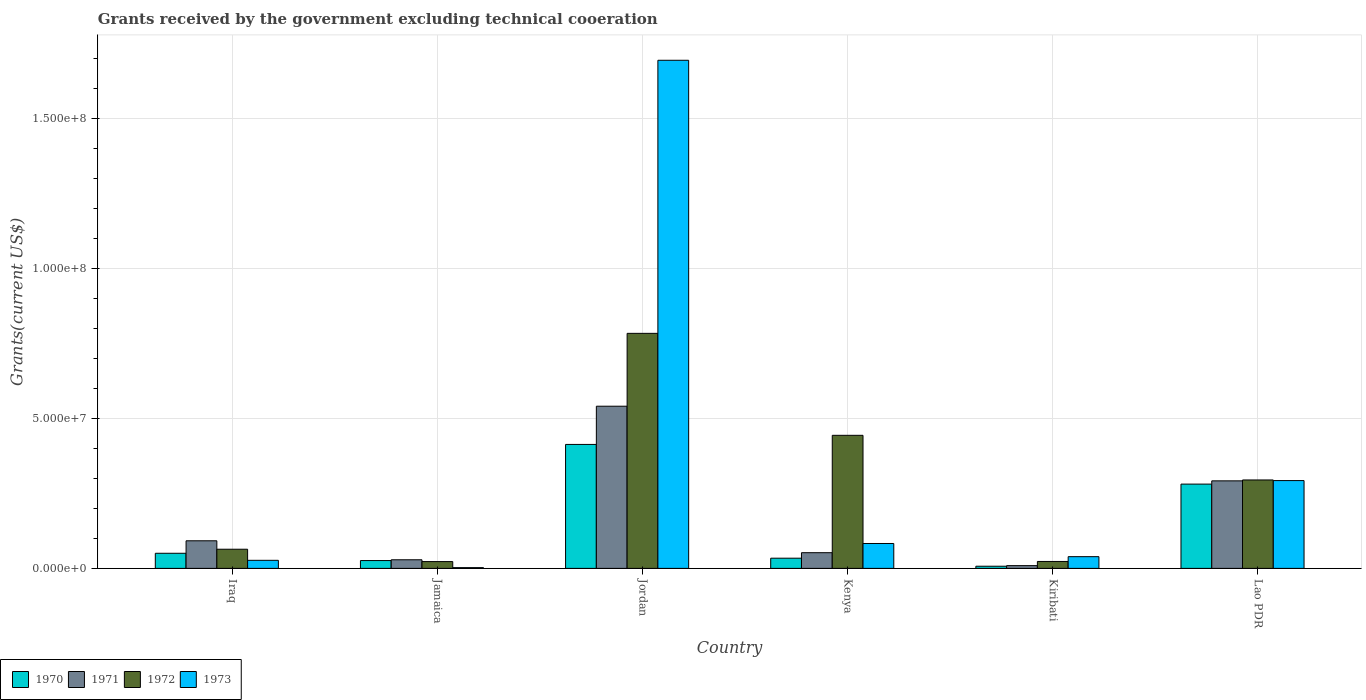Are the number of bars on each tick of the X-axis equal?
Offer a very short reply. Yes. What is the label of the 1st group of bars from the left?
Keep it short and to the point. Iraq. In how many cases, is the number of bars for a given country not equal to the number of legend labels?
Make the answer very short. 0. What is the total grants received by the government in 1972 in Lao PDR?
Give a very brief answer. 2.95e+07. Across all countries, what is the maximum total grants received by the government in 1970?
Offer a very short reply. 4.13e+07. In which country was the total grants received by the government in 1972 maximum?
Your answer should be compact. Jordan. In which country was the total grants received by the government in 1973 minimum?
Keep it short and to the point. Jamaica. What is the total total grants received by the government in 1973 in the graph?
Provide a short and direct response. 2.14e+08. What is the difference between the total grants received by the government in 1973 in Iraq and that in Jordan?
Your response must be concise. -1.67e+08. What is the difference between the total grants received by the government in 1971 in Iraq and the total grants received by the government in 1970 in Jordan?
Offer a terse response. -3.21e+07. What is the average total grants received by the government in 1970 per country?
Provide a short and direct response. 1.35e+07. In how many countries, is the total grants received by the government in 1970 greater than 150000000 US$?
Offer a terse response. 0. What is the ratio of the total grants received by the government in 1973 in Jamaica to that in Kiribati?
Make the answer very short. 0.06. Is the total grants received by the government in 1973 in Jordan less than that in Kiribati?
Give a very brief answer. No. Is the difference between the total grants received by the government in 1971 in Kenya and Kiribati greater than the difference between the total grants received by the government in 1972 in Kenya and Kiribati?
Ensure brevity in your answer.  No. What is the difference between the highest and the second highest total grants received by the government in 1973?
Provide a short and direct response. 1.61e+08. What is the difference between the highest and the lowest total grants received by the government in 1972?
Keep it short and to the point. 7.61e+07. Is it the case that in every country, the sum of the total grants received by the government in 1972 and total grants received by the government in 1971 is greater than the sum of total grants received by the government in 1973 and total grants received by the government in 1970?
Give a very brief answer. No. What does the 3rd bar from the left in Jamaica represents?
Provide a short and direct response. 1972. What does the 1st bar from the right in Kenya represents?
Provide a succinct answer. 1973. Is it the case that in every country, the sum of the total grants received by the government in 1973 and total grants received by the government in 1970 is greater than the total grants received by the government in 1972?
Your response must be concise. No. How many countries are there in the graph?
Offer a very short reply. 6. Are the values on the major ticks of Y-axis written in scientific E-notation?
Offer a terse response. Yes. Where does the legend appear in the graph?
Give a very brief answer. Bottom left. How are the legend labels stacked?
Make the answer very short. Horizontal. What is the title of the graph?
Your answer should be compact. Grants received by the government excluding technical cooeration. What is the label or title of the Y-axis?
Make the answer very short. Grants(current US$). What is the Grants(current US$) of 1970 in Iraq?
Your answer should be compact. 5.04e+06. What is the Grants(current US$) in 1971 in Iraq?
Offer a very short reply. 9.20e+06. What is the Grants(current US$) of 1972 in Iraq?
Keep it short and to the point. 6.39e+06. What is the Grants(current US$) of 1973 in Iraq?
Your response must be concise. 2.69e+06. What is the Grants(current US$) of 1970 in Jamaica?
Offer a very short reply. 2.61e+06. What is the Grants(current US$) in 1971 in Jamaica?
Keep it short and to the point. 2.87e+06. What is the Grants(current US$) of 1972 in Jamaica?
Ensure brevity in your answer.  2.27e+06. What is the Grants(current US$) of 1973 in Jamaica?
Your response must be concise. 2.50e+05. What is the Grants(current US$) in 1970 in Jordan?
Provide a succinct answer. 4.13e+07. What is the Grants(current US$) in 1971 in Jordan?
Offer a very short reply. 5.41e+07. What is the Grants(current US$) in 1972 in Jordan?
Your answer should be very brief. 7.84e+07. What is the Grants(current US$) in 1973 in Jordan?
Make the answer very short. 1.69e+08. What is the Grants(current US$) in 1970 in Kenya?
Keep it short and to the point. 3.40e+06. What is the Grants(current US$) in 1971 in Kenya?
Ensure brevity in your answer.  5.23e+06. What is the Grants(current US$) in 1972 in Kenya?
Your answer should be very brief. 4.44e+07. What is the Grants(current US$) in 1973 in Kenya?
Provide a succinct answer. 8.30e+06. What is the Grants(current US$) in 1970 in Kiribati?
Provide a short and direct response. 7.20e+05. What is the Grants(current US$) of 1971 in Kiribati?
Keep it short and to the point. 9.20e+05. What is the Grants(current US$) in 1972 in Kiribati?
Give a very brief answer. 2.31e+06. What is the Grants(current US$) in 1973 in Kiribati?
Ensure brevity in your answer.  3.91e+06. What is the Grants(current US$) of 1970 in Lao PDR?
Keep it short and to the point. 2.81e+07. What is the Grants(current US$) of 1971 in Lao PDR?
Make the answer very short. 2.92e+07. What is the Grants(current US$) of 1972 in Lao PDR?
Make the answer very short. 2.95e+07. What is the Grants(current US$) of 1973 in Lao PDR?
Offer a very short reply. 2.93e+07. Across all countries, what is the maximum Grants(current US$) in 1970?
Offer a very short reply. 4.13e+07. Across all countries, what is the maximum Grants(current US$) of 1971?
Offer a terse response. 5.41e+07. Across all countries, what is the maximum Grants(current US$) of 1972?
Keep it short and to the point. 7.84e+07. Across all countries, what is the maximum Grants(current US$) of 1973?
Provide a succinct answer. 1.69e+08. Across all countries, what is the minimum Grants(current US$) of 1970?
Offer a terse response. 7.20e+05. Across all countries, what is the minimum Grants(current US$) in 1971?
Provide a succinct answer. 9.20e+05. Across all countries, what is the minimum Grants(current US$) in 1972?
Your answer should be very brief. 2.27e+06. Across all countries, what is the minimum Grants(current US$) of 1973?
Ensure brevity in your answer.  2.50e+05. What is the total Grants(current US$) of 1970 in the graph?
Your response must be concise. 8.12e+07. What is the total Grants(current US$) in 1971 in the graph?
Make the answer very short. 1.01e+08. What is the total Grants(current US$) of 1972 in the graph?
Your response must be concise. 1.63e+08. What is the total Grants(current US$) in 1973 in the graph?
Ensure brevity in your answer.  2.14e+08. What is the difference between the Grants(current US$) of 1970 in Iraq and that in Jamaica?
Your response must be concise. 2.43e+06. What is the difference between the Grants(current US$) in 1971 in Iraq and that in Jamaica?
Provide a succinct answer. 6.33e+06. What is the difference between the Grants(current US$) in 1972 in Iraq and that in Jamaica?
Offer a very short reply. 4.12e+06. What is the difference between the Grants(current US$) of 1973 in Iraq and that in Jamaica?
Offer a very short reply. 2.44e+06. What is the difference between the Grants(current US$) of 1970 in Iraq and that in Jordan?
Make the answer very short. -3.63e+07. What is the difference between the Grants(current US$) of 1971 in Iraq and that in Jordan?
Keep it short and to the point. -4.49e+07. What is the difference between the Grants(current US$) of 1972 in Iraq and that in Jordan?
Offer a very short reply. -7.20e+07. What is the difference between the Grants(current US$) of 1973 in Iraq and that in Jordan?
Your response must be concise. -1.67e+08. What is the difference between the Grants(current US$) in 1970 in Iraq and that in Kenya?
Offer a terse response. 1.64e+06. What is the difference between the Grants(current US$) in 1971 in Iraq and that in Kenya?
Make the answer very short. 3.97e+06. What is the difference between the Grants(current US$) of 1972 in Iraq and that in Kenya?
Provide a short and direct response. -3.80e+07. What is the difference between the Grants(current US$) of 1973 in Iraq and that in Kenya?
Keep it short and to the point. -5.61e+06. What is the difference between the Grants(current US$) of 1970 in Iraq and that in Kiribati?
Provide a short and direct response. 4.32e+06. What is the difference between the Grants(current US$) of 1971 in Iraq and that in Kiribati?
Your answer should be very brief. 8.28e+06. What is the difference between the Grants(current US$) of 1972 in Iraq and that in Kiribati?
Offer a very short reply. 4.08e+06. What is the difference between the Grants(current US$) in 1973 in Iraq and that in Kiribati?
Provide a short and direct response. -1.22e+06. What is the difference between the Grants(current US$) in 1970 in Iraq and that in Lao PDR?
Ensure brevity in your answer.  -2.31e+07. What is the difference between the Grants(current US$) of 1971 in Iraq and that in Lao PDR?
Offer a very short reply. -2.00e+07. What is the difference between the Grants(current US$) of 1972 in Iraq and that in Lao PDR?
Your response must be concise. -2.31e+07. What is the difference between the Grants(current US$) in 1973 in Iraq and that in Lao PDR?
Your answer should be very brief. -2.66e+07. What is the difference between the Grants(current US$) of 1970 in Jamaica and that in Jordan?
Provide a succinct answer. -3.87e+07. What is the difference between the Grants(current US$) in 1971 in Jamaica and that in Jordan?
Make the answer very short. -5.12e+07. What is the difference between the Grants(current US$) in 1972 in Jamaica and that in Jordan?
Provide a succinct answer. -7.61e+07. What is the difference between the Grants(current US$) of 1973 in Jamaica and that in Jordan?
Offer a very short reply. -1.69e+08. What is the difference between the Grants(current US$) of 1970 in Jamaica and that in Kenya?
Your response must be concise. -7.90e+05. What is the difference between the Grants(current US$) of 1971 in Jamaica and that in Kenya?
Your answer should be compact. -2.36e+06. What is the difference between the Grants(current US$) in 1972 in Jamaica and that in Kenya?
Provide a short and direct response. -4.21e+07. What is the difference between the Grants(current US$) of 1973 in Jamaica and that in Kenya?
Your answer should be very brief. -8.05e+06. What is the difference between the Grants(current US$) of 1970 in Jamaica and that in Kiribati?
Give a very brief answer. 1.89e+06. What is the difference between the Grants(current US$) of 1971 in Jamaica and that in Kiribati?
Ensure brevity in your answer.  1.95e+06. What is the difference between the Grants(current US$) in 1972 in Jamaica and that in Kiribati?
Ensure brevity in your answer.  -4.00e+04. What is the difference between the Grants(current US$) in 1973 in Jamaica and that in Kiribati?
Your answer should be very brief. -3.66e+06. What is the difference between the Grants(current US$) of 1970 in Jamaica and that in Lao PDR?
Provide a short and direct response. -2.55e+07. What is the difference between the Grants(current US$) in 1971 in Jamaica and that in Lao PDR?
Ensure brevity in your answer.  -2.63e+07. What is the difference between the Grants(current US$) of 1972 in Jamaica and that in Lao PDR?
Provide a short and direct response. -2.72e+07. What is the difference between the Grants(current US$) in 1973 in Jamaica and that in Lao PDR?
Provide a succinct answer. -2.90e+07. What is the difference between the Grants(current US$) in 1970 in Jordan and that in Kenya?
Keep it short and to the point. 3.79e+07. What is the difference between the Grants(current US$) in 1971 in Jordan and that in Kenya?
Your answer should be compact. 4.88e+07. What is the difference between the Grants(current US$) in 1972 in Jordan and that in Kenya?
Offer a very short reply. 3.40e+07. What is the difference between the Grants(current US$) of 1973 in Jordan and that in Kenya?
Offer a terse response. 1.61e+08. What is the difference between the Grants(current US$) of 1970 in Jordan and that in Kiribati?
Your response must be concise. 4.06e+07. What is the difference between the Grants(current US$) in 1971 in Jordan and that in Kiribati?
Your response must be concise. 5.31e+07. What is the difference between the Grants(current US$) of 1972 in Jordan and that in Kiribati?
Ensure brevity in your answer.  7.60e+07. What is the difference between the Grants(current US$) in 1973 in Jordan and that in Kiribati?
Your answer should be very brief. 1.65e+08. What is the difference between the Grants(current US$) of 1970 in Jordan and that in Lao PDR?
Give a very brief answer. 1.32e+07. What is the difference between the Grants(current US$) of 1971 in Jordan and that in Lao PDR?
Your response must be concise. 2.49e+07. What is the difference between the Grants(current US$) in 1972 in Jordan and that in Lao PDR?
Provide a short and direct response. 4.89e+07. What is the difference between the Grants(current US$) of 1973 in Jordan and that in Lao PDR?
Offer a very short reply. 1.40e+08. What is the difference between the Grants(current US$) of 1970 in Kenya and that in Kiribati?
Your answer should be very brief. 2.68e+06. What is the difference between the Grants(current US$) of 1971 in Kenya and that in Kiribati?
Provide a short and direct response. 4.31e+06. What is the difference between the Grants(current US$) in 1972 in Kenya and that in Kiribati?
Ensure brevity in your answer.  4.20e+07. What is the difference between the Grants(current US$) in 1973 in Kenya and that in Kiribati?
Offer a very short reply. 4.39e+06. What is the difference between the Grants(current US$) in 1970 in Kenya and that in Lao PDR?
Your answer should be very brief. -2.47e+07. What is the difference between the Grants(current US$) of 1971 in Kenya and that in Lao PDR?
Provide a short and direct response. -2.40e+07. What is the difference between the Grants(current US$) in 1972 in Kenya and that in Lao PDR?
Provide a short and direct response. 1.49e+07. What is the difference between the Grants(current US$) of 1973 in Kenya and that in Lao PDR?
Your answer should be very brief. -2.10e+07. What is the difference between the Grants(current US$) in 1970 in Kiribati and that in Lao PDR?
Keep it short and to the point. -2.74e+07. What is the difference between the Grants(current US$) of 1971 in Kiribati and that in Lao PDR?
Your response must be concise. -2.83e+07. What is the difference between the Grants(current US$) of 1972 in Kiribati and that in Lao PDR?
Provide a short and direct response. -2.72e+07. What is the difference between the Grants(current US$) in 1973 in Kiribati and that in Lao PDR?
Offer a very short reply. -2.54e+07. What is the difference between the Grants(current US$) in 1970 in Iraq and the Grants(current US$) in 1971 in Jamaica?
Provide a succinct answer. 2.17e+06. What is the difference between the Grants(current US$) in 1970 in Iraq and the Grants(current US$) in 1972 in Jamaica?
Make the answer very short. 2.77e+06. What is the difference between the Grants(current US$) of 1970 in Iraq and the Grants(current US$) of 1973 in Jamaica?
Your answer should be very brief. 4.79e+06. What is the difference between the Grants(current US$) in 1971 in Iraq and the Grants(current US$) in 1972 in Jamaica?
Provide a short and direct response. 6.93e+06. What is the difference between the Grants(current US$) of 1971 in Iraq and the Grants(current US$) of 1973 in Jamaica?
Offer a terse response. 8.95e+06. What is the difference between the Grants(current US$) of 1972 in Iraq and the Grants(current US$) of 1973 in Jamaica?
Your response must be concise. 6.14e+06. What is the difference between the Grants(current US$) of 1970 in Iraq and the Grants(current US$) of 1971 in Jordan?
Offer a terse response. -4.90e+07. What is the difference between the Grants(current US$) of 1970 in Iraq and the Grants(current US$) of 1972 in Jordan?
Give a very brief answer. -7.33e+07. What is the difference between the Grants(current US$) of 1970 in Iraq and the Grants(current US$) of 1973 in Jordan?
Your response must be concise. -1.64e+08. What is the difference between the Grants(current US$) of 1971 in Iraq and the Grants(current US$) of 1972 in Jordan?
Your answer should be very brief. -6.92e+07. What is the difference between the Grants(current US$) of 1971 in Iraq and the Grants(current US$) of 1973 in Jordan?
Offer a very short reply. -1.60e+08. What is the difference between the Grants(current US$) in 1972 in Iraq and the Grants(current US$) in 1973 in Jordan?
Keep it short and to the point. -1.63e+08. What is the difference between the Grants(current US$) in 1970 in Iraq and the Grants(current US$) in 1972 in Kenya?
Your answer should be very brief. -3.93e+07. What is the difference between the Grants(current US$) of 1970 in Iraq and the Grants(current US$) of 1973 in Kenya?
Give a very brief answer. -3.26e+06. What is the difference between the Grants(current US$) of 1971 in Iraq and the Grants(current US$) of 1972 in Kenya?
Ensure brevity in your answer.  -3.52e+07. What is the difference between the Grants(current US$) of 1972 in Iraq and the Grants(current US$) of 1973 in Kenya?
Offer a very short reply. -1.91e+06. What is the difference between the Grants(current US$) in 1970 in Iraq and the Grants(current US$) in 1971 in Kiribati?
Give a very brief answer. 4.12e+06. What is the difference between the Grants(current US$) in 1970 in Iraq and the Grants(current US$) in 1972 in Kiribati?
Provide a succinct answer. 2.73e+06. What is the difference between the Grants(current US$) of 1970 in Iraq and the Grants(current US$) of 1973 in Kiribati?
Provide a short and direct response. 1.13e+06. What is the difference between the Grants(current US$) in 1971 in Iraq and the Grants(current US$) in 1972 in Kiribati?
Offer a terse response. 6.89e+06. What is the difference between the Grants(current US$) of 1971 in Iraq and the Grants(current US$) of 1973 in Kiribati?
Give a very brief answer. 5.29e+06. What is the difference between the Grants(current US$) of 1972 in Iraq and the Grants(current US$) of 1973 in Kiribati?
Ensure brevity in your answer.  2.48e+06. What is the difference between the Grants(current US$) of 1970 in Iraq and the Grants(current US$) of 1971 in Lao PDR?
Ensure brevity in your answer.  -2.41e+07. What is the difference between the Grants(current US$) of 1970 in Iraq and the Grants(current US$) of 1972 in Lao PDR?
Provide a succinct answer. -2.44e+07. What is the difference between the Grants(current US$) in 1970 in Iraq and the Grants(current US$) in 1973 in Lao PDR?
Give a very brief answer. -2.42e+07. What is the difference between the Grants(current US$) in 1971 in Iraq and the Grants(current US$) in 1972 in Lao PDR?
Your answer should be very brief. -2.03e+07. What is the difference between the Grants(current US$) in 1971 in Iraq and the Grants(current US$) in 1973 in Lao PDR?
Provide a succinct answer. -2.01e+07. What is the difference between the Grants(current US$) of 1972 in Iraq and the Grants(current US$) of 1973 in Lao PDR?
Give a very brief answer. -2.29e+07. What is the difference between the Grants(current US$) of 1970 in Jamaica and the Grants(current US$) of 1971 in Jordan?
Your response must be concise. -5.14e+07. What is the difference between the Grants(current US$) in 1970 in Jamaica and the Grants(current US$) in 1972 in Jordan?
Offer a terse response. -7.57e+07. What is the difference between the Grants(current US$) of 1970 in Jamaica and the Grants(current US$) of 1973 in Jordan?
Ensure brevity in your answer.  -1.67e+08. What is the difference between the Grants(current US$) of 1971 in Jamaica and the Grants(current US$) of 1972 in Jordan?
Keep it short and to the point. -7.55e+07. What is the difference between the Grants(current US$) of 1971 in Jamaica and the Grants(current US$) of 1973 in Jordan?
Offer a very short reply. -1.67e+08. What is the difference between the Grants(current US$) of 1972 in Jamaica and the Grants(current US$) of 1973 in Jordan?
Give a very brief answer. -1.67e+08. What is the difference between the Grants(current US$) of 1970 in Jamaica and the Grants(current US$) of 1971 in Kenya?
Provide a short and direct response. -2.62e+06. What is the difference between the Grants(current US$) in 1970 in Jamaica and the Grants(current US$) in 1972 in Kenya?
Your response must be concise. -4.18e+07. What is the difference between the Grants(current US$) of 1970 in Jamaica and the Grants(current US$) of 1973 in Kenya?
Offer a very short reply. -5.69e+06. What is the difference between the Grants(current US$) in 1971 in Jamaica and the Grants(current US$) in 1972 in Kenya?
Provide a short and direct response. -4.15e+07. What is the difference between the Grants(current US$) of 1971 in Jamaica and the Grants(current US$) of 1973 in Kenya?
Your answer should be compact. -5.43e+06. What is the difference between the Grants(current US$) of 1972 in Jamaica and the Grants(current US$) of 1973 in Kenya?
Provide a short and direct response. -6.03e+06. What is the difference between the Grants(current US$) in 1970 in Jamaica and the Grants(current US$) in 1971 in Kiribati?
Keep it short and to the point. 1.69e+06. What is the difference between the Grants(current US$) in 1970 in Jamaica and the Grants(current US$) in 1973 in Kiribati?
Offer a very short reply. -1.30e+06. What is the difference between the Grants(current US$) of 1971 in Jamaica and the Grants(current US$) of 1972 in Kiribati?
Offer a very short reply. 5.60e+05. What is the difference between the Grants(current US$) of 1971 in Jamaica and the Grants(current US$) of 1973 in Kiribati?
Give a very brief answer. -1.04e+06. What is the difference between the Grants(current US$) in 1972 in Jamaica and the Grants(current US$) in 1973 in Kiribati?
Keep it short and to the point. -1.64e+06. What is the difference between the Grants(current US$) of 1970 in Jamaica and the Grants(current US$) of 1971 in Lao PDR?
Keep it short and to the point. -2.66e+07. What is the difference between the Grants(current US$) of 1970 in Jamaica and the Grants(current US$) of 1972 in Lao PDR?
Your answer should be very brief. -2.69e+07. What is the difference between the Grants(current US$) in 1970 in Jamaica and the Grants(current US$) in 1973 in Lao PDR?
Provide a succinct answer. -2.67e+07. What is the difference between the Grants(current US$) of 1971 in Jamaica and the Grants(current US$) of 1972 in Lao PDR?
Your answer should be compact. -2.66e+07. What is the difference between the Grants(current US$) of 1971 in Jamaica and the Grants(current US$) of 1973 in Lao PDR?
Your answer should be compact. -2.64e+07. What is the difference between the Grants(current US$) in 1972 in Jamaica and the Grants(current US$) in 1973 in Lao PDR?
Ensure brevity in your answer.  -2.70e+07. What is the difference between the Grants(current US$) of 1970 in Jordan and the Grants(current US$) of 1971 in Kenya?
Make the answer very short. 3.61e+07. What is the difference between the Grants(current US$) in 1970 in Jordan and the Grants(current US$) in 1972 in Kenya?
Offer a very short reply. -3.04e+06. What is the difference between the Grants(current US$) of 1970 in Jordan and the Grants(current US$) of 1973 in Kenya?
Make the answer very short. 3.30e+07. What is the difference between the Grants(current US$) in 1971 in Jordan and the Grants(current US$) in 1972 in Kenya?
Offer a very short reply. 9.70e+06. What is the difference between the Grants(current US$) of 1971 in Jordan and the Grants(current US$) of 1973 in Kenya?
Keep it short and to the point. 4.58e+07. What is the difference between the Grants(current US$) in 1972 in Jordan and the Grants(current US$) in 1973 in Kenya?
Provide a succinct answer. 7.00e+07. What is the difference between the Grants(current US$) in 1970 in Jordan and the Grants(current US$) in 1971 in Kiribati?
Offer a terse response. 4.04e+07. What is the difference between the Grants(current US$) in 1970 in Jordan and the Grants(current US$) in 1972 in Kiribati?
Your answer should be compact. 3.90e+07. What is the difference between the Grants(current US$) of 1970 in Jordan and the Grants(current US$) of 1973 in Kiribati?
Give a very brief answer. 3.74e+07. What is the difference between the Grants(current US$) of 1971 in Jordan and the Grants(current US$) of 1972 in Kiribati?
Keep it short and to the point. 5.18e+07. What is the difference between the Grants(current US$) of 1971 in Jordan and the Grants(current US$) of 1973 in Kiribati?
Your answer should be very brief. 5.02e+07. What is the difference between the Grants(current US$) of 1972 in Jordan and the Grants(current US$) of 1973 in Kiribati?
Offer a very short reply. 7.44e+07. What is the difference between the Grants(current US$) of 1970 in Jordan and the Grants(current US$) of 1971 in Lao PDR?
Provide a succinct answer. 1.21e+07. What is the difference between the Grants(current US$) of 1970 in Jordan and the Grants(current US$) of 1972 in Lao PDR?
Ensure brevity in your answer.  1.18e+07. What is the difference between the Grants(current US$) of 1970 in Jordan and the Grants(current US$) of 1973 in Lao PDR?
Your answer should be compact. 1.20e+07. What is the difference between the Grants(current US$) in 1971 in Jordan and the Grants(current US$) in 1972 in Lao PDR?
Give a very brief answer. 2.46e+07. What is the difference between the Grants(current US$) of 1971 in Jordan and the Grants(current US$) of 1973 in Lao PDR?
Offer a very short reply. 2.48e+07. What is the difference between the Grants(current US$) of 1972 in Jordan and the Grants(current US$) of 1973 in Lao PDR?
Your response must be concise. 4.91e+07. What is the difference between the Grants(current US$) in 1970 in Kenya and the Grants(current US$) in 1971 in Kiribati?
Provide a succinct answer. 2.48e+06. What is the difference between the Grants(current US$) of 1970 in Kenya and the Grants(current US$) of 1972 in Kiribati?
Provide a short and direct response. 1.09e+06. What is the difference between the Grants(current US$) in 1970 in Kenya and the Grants(current US$) in 1973 in Kiribati?
Your answer should be very brief. -5.10e+05. What is the difference between the Grants(current US$) in 1971 in Kenya and the Grants(current US$) in 1972 in Kiribati?
Provide a short and direct response. 2.92e+06. What is the difference between the Grants(current US$) of 1971 in Kenya and the Grants(current US$) of 1973 in Kiribati?
Ensure brevity in your answer.  1.32e+06. What is the difference between the Grants(current US$) of 1972 in Kenya and the Grants(current US$) of 1973 in Kiribati?
Your answer should be compact. 4.04e+07. What is the difference between the Grants(current US$) in 1970 in Kenya and the Grants(current US$) in 1971 in Lao PDR?
Make the answer very short. -2.58e+07. What is the difference between the Grants(current US$) in 1970 in Kenya and the Grants(current US$) in 1972 in Lao PDR?
Your response must be concise. -2.61e+07. What is the difference between the Grants(current US$) in 1970 in Kenya and the Grants(current US$) in 1973 in Lao PDR?
Your answer should be very brief. -2.59e+07. What is the difference between the Grants(current US$) in 1971 in Kenya and the Grants(current US$) in 1972 in Lao PDR?
Your response must be concise. -2.42e+07. What is the difference between the Grants(current US$) of 1971 in Kenya and the Grants(current US$) of 1973 in Lao PDR?
Provide a short and direct response. -2.40e+07. What is the difference between the Grants(current US$) of 1972 in Kenya and the Grants(current US$) of 1973 in Lao PDR?
Your response must be concise. 1.51e+07. What is the difference between the Grants(current US$) in 1970 in Kiribati and the Grants(current US$) in 1971 in Lao PDR?
Your response must be concise. -2.85e+07. What is the difference between the Grants(current US$) in 1970 in Kiribati and the Grants(current US$) in 1972 in Lao PDR?
Keep it short and to the point. -2.88e+07. What is the difference between the Grants(current US$) of 1970 in Kiribati and the Grants(current US$) of 1973 in Lao PDR?
Offer a very short reply. -2.86e+07. What is the difference between the Grants(current US$) of 1971 in Kiribati and the Grants(current US$) of 1972 in Lao PDR?
Provide a succinct answer. -2.86e+07. What is the difference between the Grants(current US$) of 1971 in Kiribati and the Grants(current US$) of 1973 in Lao PDR?
Ensure brevity in your answer.  -2.84e+07. What is the difference between the Grants(current US$) of 1972 in Kiribati and the Grants(current US$) of 1973 in Lao PDR?
Keep it short and to the point. -2.70e+07. What is the average Grants(current US$) of 1970 per country?
Offer a very short reply. 1.35e+07. What is the average Grants(current US$) of 1971 per country?
Your answer should be very brief. 1.69e+07. What is the average Grants(current US$) of 1972 per country?
Your answer should be compact. 2.72e+07. What is the average Grants(current US$) of 1973 per country?
Keep it short and to the point. 3.56e+07. What is the difference between the Grants(current US$) in 1970 and Grants(current US$) in 1971 in Iraq?
Your response must be concise. -4.16e+06. What is the difference between the Grants(current US$) in 1970 and Grants(current US$) in 1972 in Iraq?
Make the answer very short. -1.35e+06. What is the difference between the Grants(current US$) in 1970 and Grants(current US$) in 1973 in Iraq?
Give a very brief answer. 2.35e+06. What is the difference between the Grants(current US$) of 1971 and Grants(current US$) of 1972 in Iraq?
Your answer should be very brief. 2.81e+06. What is the difference between the Grants(current US$) in 1971 and Grants(current US$) in 1973 in Iraq?
Make the answer very short. 6.51e+06. What is the difference between the Grants(current US$) of 1972 and Grants(current US$) of 1973 in Iraq?
Your answer should be very brief. 3.70e+06. What is the difference between the Grants(current US$) in 1970 and Grants(current US$) in 1971 in Jamaica?
Provide a succinct answer. -2.60e+05. What is the difference between the Grants(current US$) of 1970 and Grants(current US$) of 1972 in Jamaica?
Ensure brevity in your answer.  3.40e+05. What is the difference between the Grants(current US$) in 1970 and Grants(current US$) in 1973 in Jamaica?
Your answer should be very brief. 2.36e+06. What is the difference between the Grants(current US$) in 1971 and Grants(current US$) in 1972 in Jamaica?
Provide a succinct answer. 6.00e+05. What is the difference between the Grants(current US$) of 1971 and Grants(current US$) of 1973 in Jamaica?
Make the answer very short. 2.62e+06. What is the difference between the Grants(current US$) of 1972 and Grants(current US$) of 1973 in Jamaica?
Offer a terse response. 2.02e+06. What is the difference between the Grants(current US$) of 1970 and Grants(current US$) of 1971 in Jordan?
Keep it short and to the point. -1.27e+07. What is the difference between the Grants(current US$) in 1970 and Grants(current US$) in 1972 in Jordan?
Your answer should be compact. -3.70e+07. What is the difference between the Grants(current US$) in 1970 and Grants(current US$) in 1973 in Jordan?
Provide a succinct answer. -1.28e+08. What is the difference between the Grants(current US$) of 1971 and Grants(current US$) of 1972 in Jordan?
Your answer should be compact. -2.43e+07. What is the difference between the Grants(current US$) of 1971 and Grants(current US$) of 1973 in Jordan?
Provide a short and direct response. -1.15e+08. What is the difference between the Grants(current US$) of 1972 and Grants(current US$) of 1973 in Jordan?
Offer a terse response. -9.10e+07. What is the difference between the Grants(current US$) in 1970 and Grants(current US$) in 1971 in Kenya?
Make the answer very short. -1.83e+06. What is the difference between the Grants(current US$) of 1970 and Grants(current US$) of 1972 in Kenya?
Provide a short and direct response. -4.10e+07. What is the difference between the Grants(current US$) in 1970 and Grants(current US$) in 1973 in Kenya?
Your answer should be very brief. -4.90e+06. What is the difference between the Grants(current US$) in 1971 and Grants(current US$) in 1972 in Kenya?
Your answer should be compact. -3.91e+07. What is the difference between the Grants(current US$) in 1971 and Grants(current US$) in 1973 in Kenya?
Your answer should be very brief. -3.07e+06. What is the difference between the Grants(current US$) of 1972 and Grants(current US$) of 1973 in Kenya?
Make the answer very short. 3.61e+07. What is the difference between the Grants(current US$) of 1970 and Grants(current US$) of 1972 in Kiribati?
Offer a very short reply. -1.59e+06. What is the difference between the Grants(current US$) of 1970 and Grants(current US$) of 1973 in Kiribati?
Your answer should be very brief. -3.19e+06. What is the difference between the Grants(current US$) of 1971 and Grants(current US$) of 1972 in Kiribati?
Your answer should be very brief. -1.39e+06. What is the difference between the Grants(current US$) in 1971 and Grants(current US$) in 1973 in Kiribati?
Provide a short and direct response. -2.99e+06. What is the difference between the Grants(current US$) of 1972 and Grants(current US$) of 1973 in Kiribati?
Your response must be concise. -1.60e+06. What is the difference between the Grants(current US$) in 1970 and Grants(current US$) in 1971 in Lao PDR?
Provide a succinct answer. -1.08e+06. What is the difference between the Grants(current US$) in 1970 and Grants(current US$) in 1972 in Lao PDR?
Offer a terse response. -1.38e+06. What is the difference between the Grants(current US$) of 1970 and Grants(current US$) of 1973 in Lao PDR?
Provide a succinct answer. -1.17e+06. What is the difference between the Grants(current US$) in 1971 and Grants(current US$) in 1973 in Lao PDR?
Ensure brevity in your answer.  -9.00e+04. What is the ratio of the Grants(current US$) in 1970 in Iraq to that in Jamaica?
Keep it short and to the point. 1.93. What is the ratio of the Grants(current US$) in 1971 in Iraq to that in Jamaica?
Your response must be concise. 3.21. What is the ratio of the Grants(current US$) of 1972 in Iraq to that in Jamaica?
Keep it short and to the point. 2.81. What is the ratio of the Grants(current US$) of 1973 in Iraq to that in Jamaica?
Offer a very short reply. 10.76. What is the ratio of the Grants(current US$) of 1970 in Iraq to that in Jordan?
Give a very brief answer. 0.12. What is the ratio of the Grants(current US$) in 1971 in Iraq to that in Jordan?
Provide a succinct answer. 0.17. What is the ratio of the Grants(current US$) in 1972 in Iraq to that in Jordan?
Give a very brief answer. 0.08. What is the ratio of the Grants(current US$) in 1973 in Iraq to that in Jordan?
Ensure brevity in your answer.  0.02. What is the ratio of the Grants(current US$) of 1970 in Iraq to that in Kenya?
Your answer should be very brief. 1.48. What is the ratio of the Grants(current US$) of 1971 in Iraq to that in Kenya?
Make the answer very short. 1.76. What is the ratio of the Grants(current US$) of 1972 in Iraq to that in Kenya?
Your response must be concise. 0.14. What is the ratio of the Grants(current US$) in 1973 in Iraq to that in Kenya?
Offer a terse response. 0.32. What is the ratio of the Grants(current US$) in 1970 in Iraq to that in Kiribati?
Your answer should be compact. 7. What is the ratio of the Grants(current US$) in 1971 in Iraq to that in Kiribati?
Keep it short and to the point. 10. What is the ratio of the Grants(current US$) of 1972 in Iraq to that in Kiribati?
Your response must be concise. 2.77. What is the ratio of the Grants(current US$) in 1973 in Iraq to that in Kiribati?
Provide a succinct answer. 0.69. What is the ratio of the Grants(current US$) in 1970 in Iraq to that in Lao PDR?
Your response must be concise. 0.18. What is the ratio of the Grants(current US$) of 1971 in Iraq to that in Lao PDR?
Offer a very short reply. 0.32. What is the ratio of the Grants(current US$) of 1972 in Iraq to that in Lao PDR?
Offer a very short reply. 0.22. What is the ratio of the Grants(current US$) of 1973 in Iraq to that in Lao PDR?
Provide a short and direct response. 0.09. What is the ratio of the Grants(current US$) in 1970 in Jamaica to that in Jordan?
Your answer should be compact. 0.06. What is the ratio of the Grants(current US$) of 1971 in Jamaica to that in Jordan?
Offer a very short reply. 0.05. What is the ratio of the Grants(current US$) in 1972 in Jamaica to that in Jordan?
Your answer should be very brief. 0.03. What is the ratio of the Grants(current US$) in 1973 in Jamaica to that in Jordan?
Offer a very short reply. 0. What is the ratio of the Grants(current US$) in 1970 in Jamaica to that in Kenya?
Provide a succinct answer. 0.77. What is the ratio of the Grants(current US$) of 1971 in Jamaica to that in Kenya?
Provide a succinct answer. 0.55. What is the ratio of the Grants(current US$) in 1972 in Jamaica to that in Kenya?
Make the answer very short. 0.05. What is the ratio of the Grants(current US$) in 1973 in Jamaica to that in Kenya?
Offer a very short reply. 0.03. What is the ratio of the Grants(current US$) in 1970 in Jamaica to that in Kiribati?
Ensure brevity in your answer.  3.62. What is the ratio of the Grants(current US$) of 1971 in Jamaica to that in Kiribati?
Your answer should be compact. 3.12. What is the ratio of the Grants(current US$) in 1972 in Jamaica to that in Kiribati?
Give a very brief answer. 0.98. What is the ratio of the Grants(current US$) of 1973 in Jamaica to that in Kiribati?
Give a very brief answer. 0.06. What is the ratio of the Grants(current US$) of 1970 in Jamaica to that in Lao PDR?
Your answer should be compact. 0.09. What is the ratio of the Grants(current US$) in 1971 in Jamaica to that in Lao PDR?
Your answer should be very brief. 0.1. What is the ratio of the Grants(current US$) of 1972 in Jamaica to that in Lao PDR?
Your answer should be very brief. 0.08. What is the ratio of the Grants(current US$) of 1973 in Jamaica to that in Lao PDR?
Offer a very short reply. 0.01. What is the ratio of the Grants(current US$) in 1970 in Jordan to that in Kenya?
Your answer should be compact. 12.15. What is the ratio of the Grants(current US$) in 1971 in Jordan to that in Kenya?
Ensure brevity in your answer.  10.34. What is the ratio of the Grants(current US$) in 1972 in Jordan to that in Kenya?
Offer a terse response. 1.77. What is the ratio of the Grants(current US$) in 1973 in Jordan to that in Kenya?
Provide a succinct answer. 20.41. What is the ratio of the Grants(current US$) of 1970 in Jordan to that in Kiribati?
Offer a very short reply. 57.39. What is the ratio of the Grants(current US$) in 1971 in Jordan to that in Kiribati?
Your answer should be very brief. 58.76. What is the ratio of the Grants(current US$) of 1972 in Jordan to that in Kiribati?
Provide a succinct answer. 33.92. What is the ratio of the Grants(current US$) of 1973 in Jordan to that in Kiribati?
Provide a short and direct response. 43.32. What is the ratio of the Grants(current US$) in 1970 in Jordan to that in Lao PDR?
Offer a terse response. 1.47. What is the ratio of the Grants(current US$) in 1971 in Jordan to that in Lao PDR?
Offer a very short reply. 1.85. What is the ratio of the Grants(current US$) of 1972 in Jordan to that in Lao PDR?
Provide a succinct answer. 2.66. What is the ratio of the Grants(current US$) of 1973 in Jordan to that in Lao PDR?
Ensure brevity in your answer.  5.79. What is the ratio of the Grants(current US$) in 1970 in Kenya to that in Kiribati?
Your answer should be very brief. 4.72. What is the ratio of the Grants(current US$) of 1971 in Kenya to that in Kiribati?
Offer a terse response. 5.68. What is the ratio of the Grants(current US$) in 1972 in Kenya to that in Kiribati?
Make the answer very short. 19.2. What is the ratio of the Grants(current US$) in 1973 in Kenya to that in Kiribati?
Your response must be concise. 2.12. What is the ratio of the Grants(current US$) of 1970 in Kenya to that in Lao PDR?
Offer a very short reply. 0.12. What is the ratio of the Grants(current US$) in 1971 in Kenya to that in Lao PDR?
Keep it short and to the point. 0.18. What is the ratio of the Grants(current US$) of 1972 in Kenya to that in Lao PDR?
Provide a succinct answer. 1.5. What is the ratio of the Grants(current US$) in 1973 in Kenya to that in Lao PDR?
Offer a terse response. 0.28. What is the ratio of the Grants(current US$) of 1970 in Kiribati to that in Lao PDR?
Offer a terse response. 0.03. What is the ratio of the Grants(current US$) in 1971 in Kiribati to that in Lao PDR?
Your answer should be compact. 0.03. What is the ratio of the Grants(current US$) in 1972 in Kiribati to that in Lao PDR?
Offer a terse response. 0.08. What is the ratio of the Grants(current US$) of 1973 in Kiribati to that in Lao PDR?
Ensure brevity in your answer.  0.13. What is the difference between the highest and the second highest Grants(current US$) of 1970?
Offer a terse response. 1.32e+07. What is the difference between the highest and the second highest Grants(current US$) of 1971?
Provide a succinct answer. 2.49e+07. What is the difference between the highest and the second highest Grants(current US$) in 1972?
Provide a succinct answer. 3.40e+07. What is the difference between the highest and the second highest Grants(current US$) of 1973?
Give a very brief answer. 1.40e+08. What is the difference between the highest and the lowest Grants(current US$) in 1970?
Your response must be concise. 4.06e+07. What is the difference between the highest and the lowest Grants(current US$) in 1971?
Provide a succinct answer. 5.31e+07. What is the difference between the highest and the lowest Grants(current US$) of 1972?
Make the answer very short. 7.61e+07. What is the difference between the highest and the lowest Grants(current US$) of 1973?
Keep it short and to the point. 1.69e+08. 